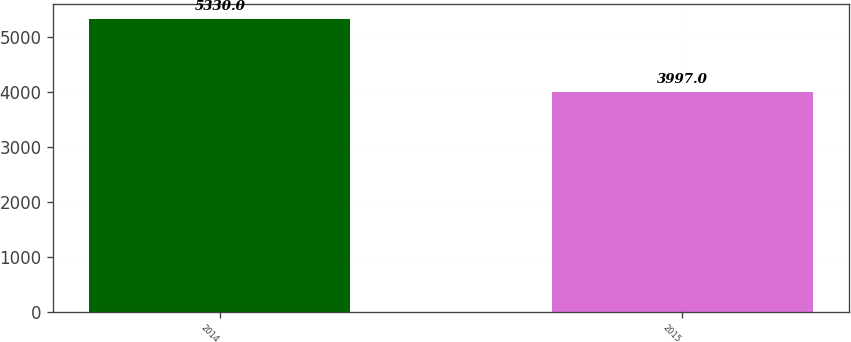Convert chart. <chart><loc_0><loc_0><loc_500><loc_500><bar_chart><fcel>2014<fcel>2015<nl><fcel>5330<fcel>3997<nl></chart> 